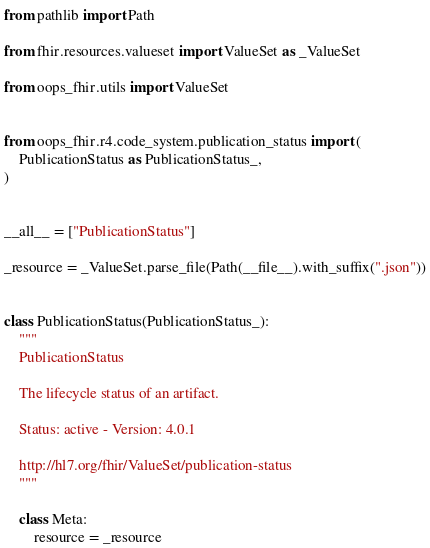Convert code to text. <code><loc_0><loc_0><loc_500><loc_500><_Python_>from pathlib import Path

from fhir.resources.valueset import ValueSet as _ValueSet

from oops_fhir.utils import ValueSet


from oops_fhir.r4.code_system.publication_status import (
    PublicationStatus as PublicationStatus_,
)


__all__ = ["PublicationStatus"]

_resource = _ValueSet.parse_file(Path(__file__).with_suffix(".json"))


class PublicationStatus(PublicationStatus_):
    """
    PublicationStatus

    The lifecycle status of an artifact.

    Status: active - Version: 4.0.1

    http://hl7.org/fhir/ValueSet/publication-status
    """

    class Meta:
        resource = _resource
</code> 